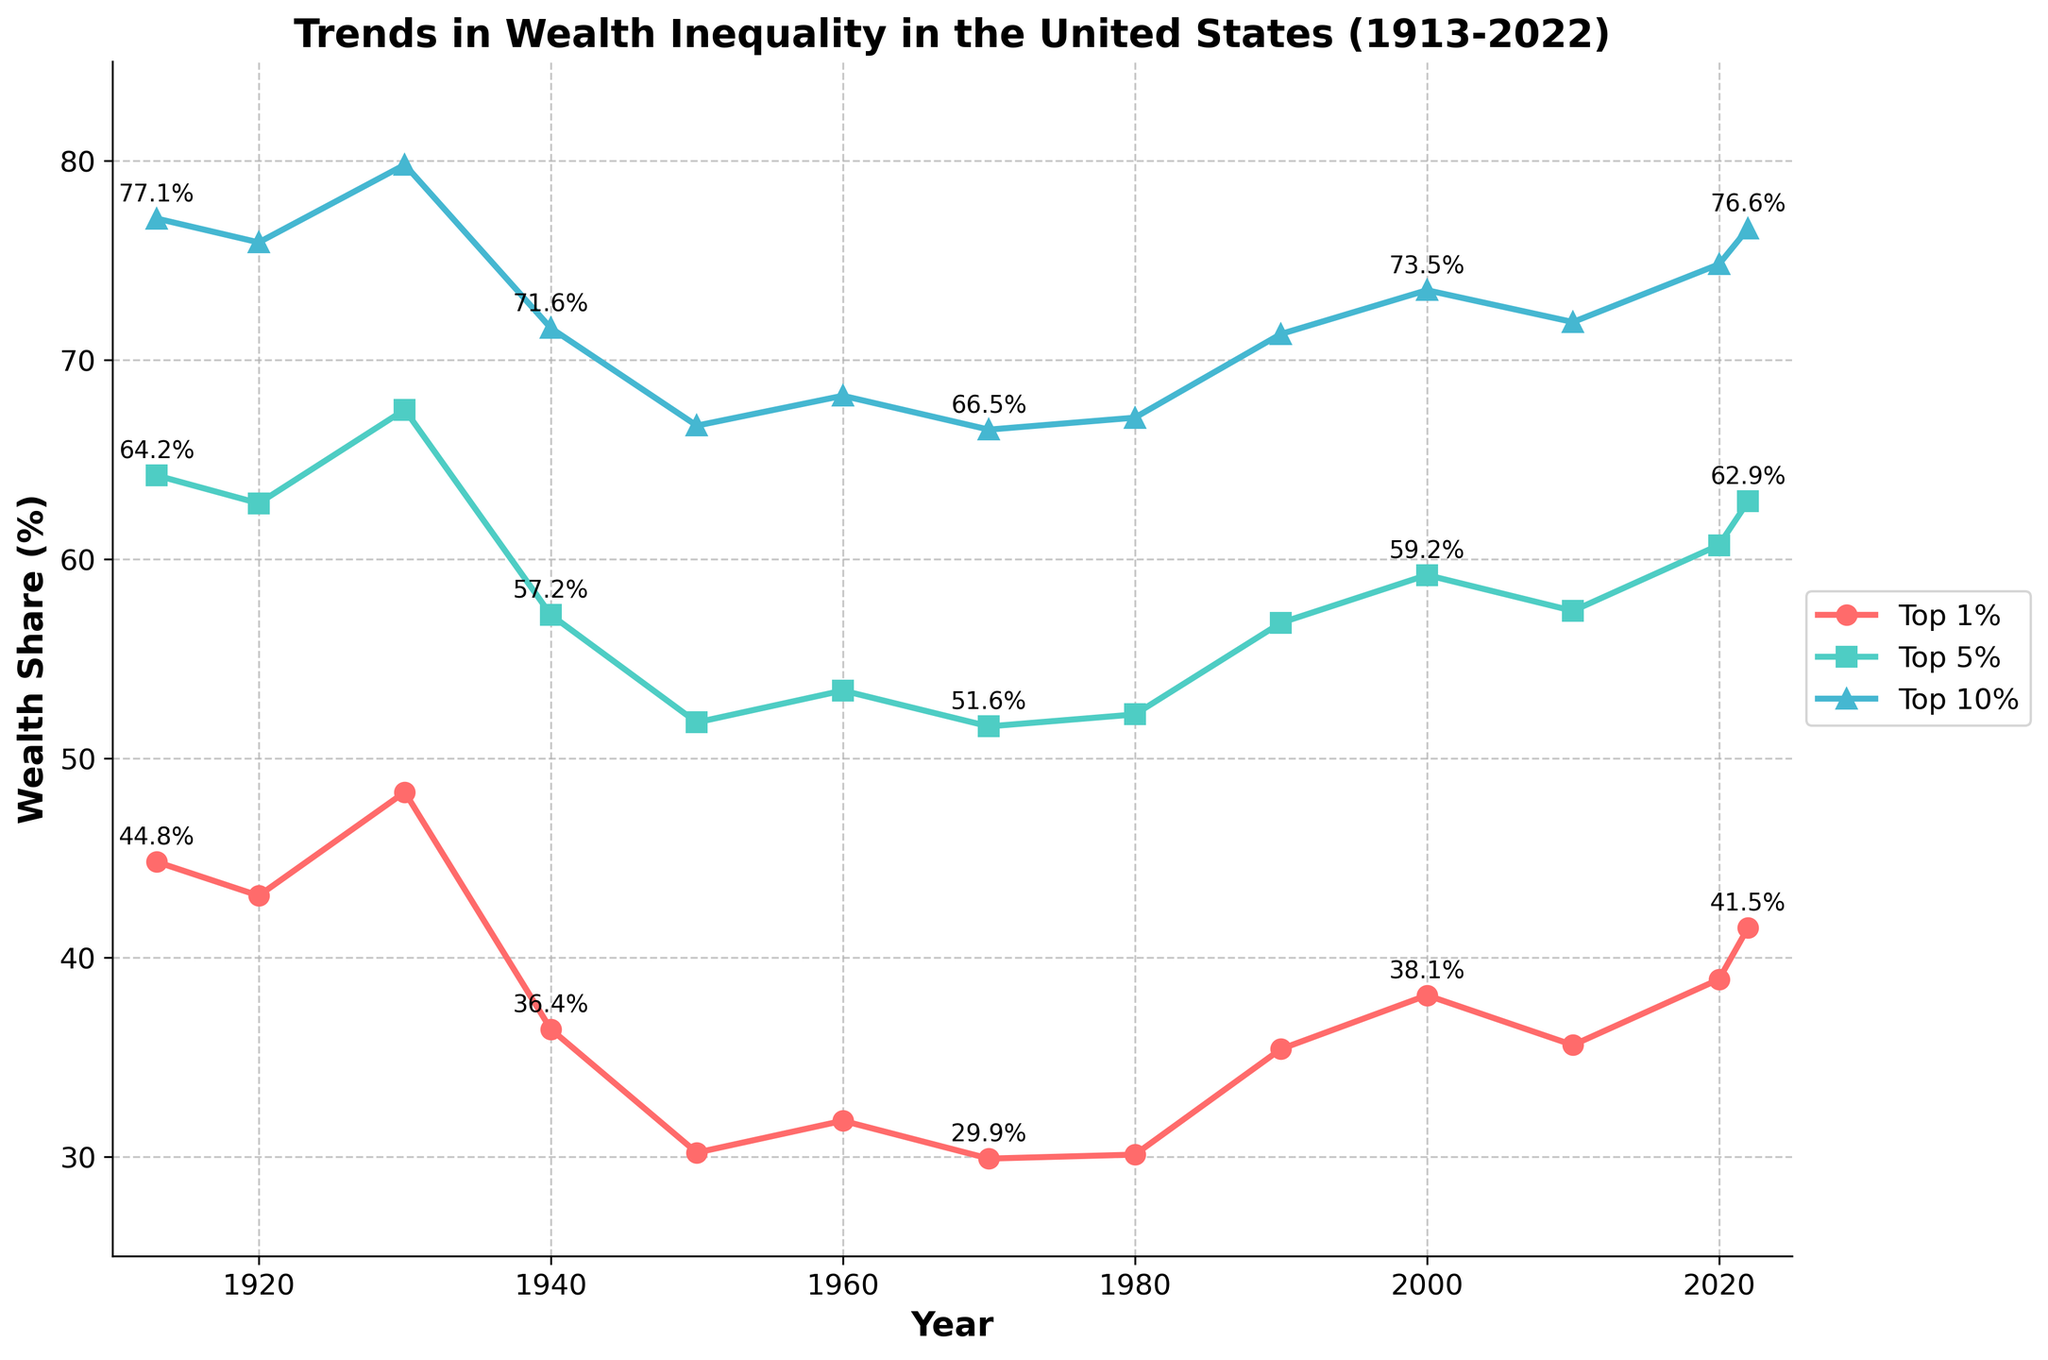What trend do you observe in the wealth share of the top 1% from 1913 to 2022? The top 1% wealth share starts at 44.8% in 1913 and fluctuates over the years. It peaks around 1930, drops to its lowest around 1940-1950, and then rises again, reaching 41.5% in 2022.
Answer: A U-shaped trend How does the wealth share of the top 10% in 2022 compare to its wealth share in 1913? In 1913, the top 10% wealth share is 77.1%. In 2022, it is 76.6%. By comparing these values, the wealth share of the top 10% slightly decreases by 0.5 percentage points over the period.
Answer: Decreased by 0.5 percentage points What is the difference in the wealth share of the top 1% and the top 5% in 2022? For 2022, the top 1% wealth share is 41.5%, and the top 5% wealth share is 62.9%. The difference is calculated as 62.9% - 41.5% = 21.4%.
Answer: 21.4 percentage points Between which two decades did the top 5% wealth share experience the most significant increase? Comparing each consecutive decade, the most significant increase for the top 5% occurs between 2010 (57.4%) and 2020 (60.7%), which is an increase of 3.3 percentage points.
Answer: Between 2010 and 2020 In which year did the top 1% wealth share have the lowest value, and what was that value? Observing the plot, the top 1% wealth share has its lowest value around 1950, where it is at 30.2%.
Answer: 1950, 30.2% How do the trends of the top 1% and top 10% wealth shares compare between 1970 and 2022? Between 1970 and 2022, the top 1% wealth share increases from 29.9% to 41.5%, showing a rising trend. The top 10% wealth share increases from 66.5% to 76.6%, also showing a rising trend. Both trends are increasing, but the top 1% has a steeper incline.
Answer: Both increased, with the top 1% having a steeper incline What was the average wealth share of the top 1% over the entire period? Adding all the top 1% wealth shares from 1913 to 2022 (44.8 + 43.1 + 48.3 + 36.4 + 30.2 + 31.8 + 29.9 + 30.1 + 35.4 + 38.1 + 35.6 + 38.9 + 41.5 = 484.1) and dividing by the number of data points (13), the average is 484.1 / 13 = 37.2%.
Answer: 37.2% Which group (top 1%, 5%, or 10%) had the closest average wealth share to 60% over the period shown? Calculating the averages for each group: Top 1% (484.1 / 13 = 37.2%), Top 5% ((64.2 + 62.8 + 67.5 + 57.2 + 51.8 + 53.4 + 51.6 + 52.2 + 56.8 + 59.2 + 57.4 + 60.7 + 62.9) / 13 ≈ 58.1%), Top 10% ((77.1 + 75.9 + 79.8 + 71.6 + 66.7 + 68.2 + 66.5 + 67.1 + 71.3 + 73.5 + 71.9 + 74.8 + 76.6) / 13 ≈ 72.8%). The closest to 60% is the top 5% with an average of 58.1%.
Answer: Top 5% 